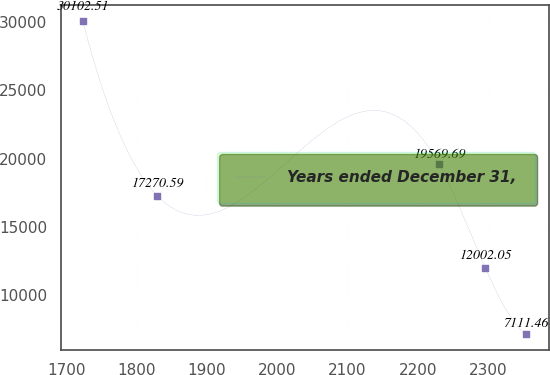Convert chart to OTSL. <chart><loc_0><loc_0><loc_500><loc_500><line_chart><ecel><fcel>Years ended December 31,<nl><fcel>1723.28<fcel>30102.5<nl><fcel>1829.28<fcel>17270.6<nl><fcel>2230.44<fcel>19569.7<nl><fcel>2296<fcel>12002<nl><fcel>2354.56<fcel>7111.46<nl></chart> 